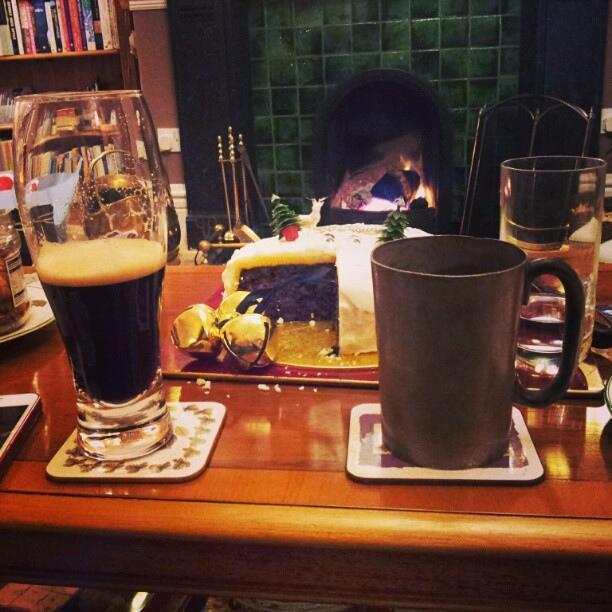How many bells are sitting on the table?
Give a very brief answer. 2. How many cups are in the picture?
Give a very brief answer. 3. How many people are out in the water?
Give a very brief answer. 0. 